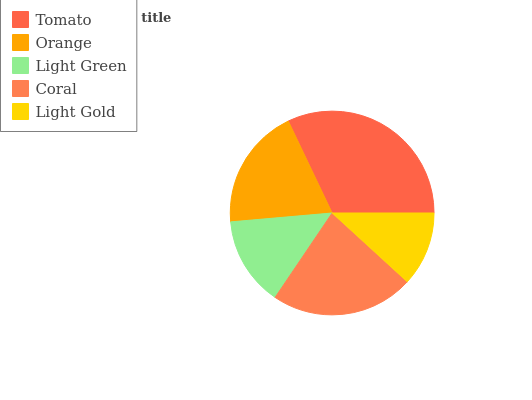Is Light Gold the minimum?
Answer yes or no. Yes. Is Tomato the maximum?
Answer yes or no. Yes. Is Orange the minimum?
Answer yes or no. No. Is Orange the maximum?
Answer yes or no. No. Is Tomato greater than Orange?
Answer yes or no. Yes. Is Orange less than Tomato?
Answer yes or no. Yes. Is Orange greater than Tomato?
Answer yes or no. No. Is Tomato less than Orange?
Answer yes or no. No. Is Orange the high median?
Answer yes or no. Yes. Is Orange the low median?
Answer yes or no. Yes. Is Light Green the high median?
Answer yes or no. No. Is Light Gold the low median?
Answer yes or no. No. 